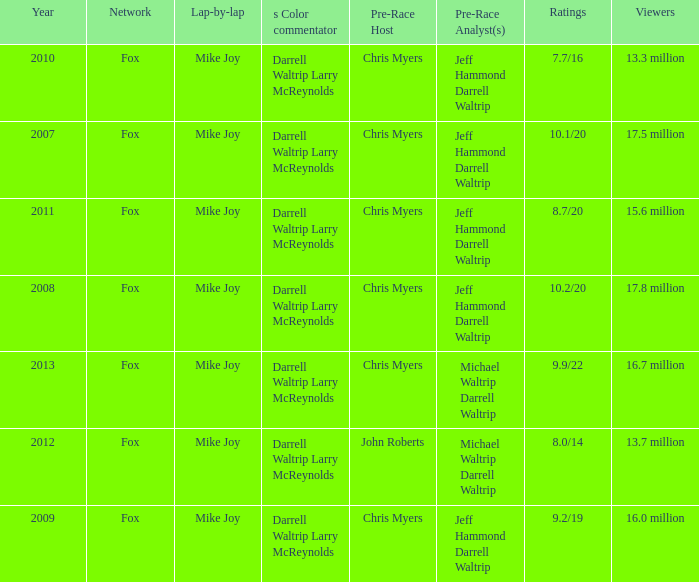What Lap-by-lap has Chris Myers as the Pre-Race Host, a Year larger than 2008, and 9.9/22 as its Ratings? Mike Joy. 